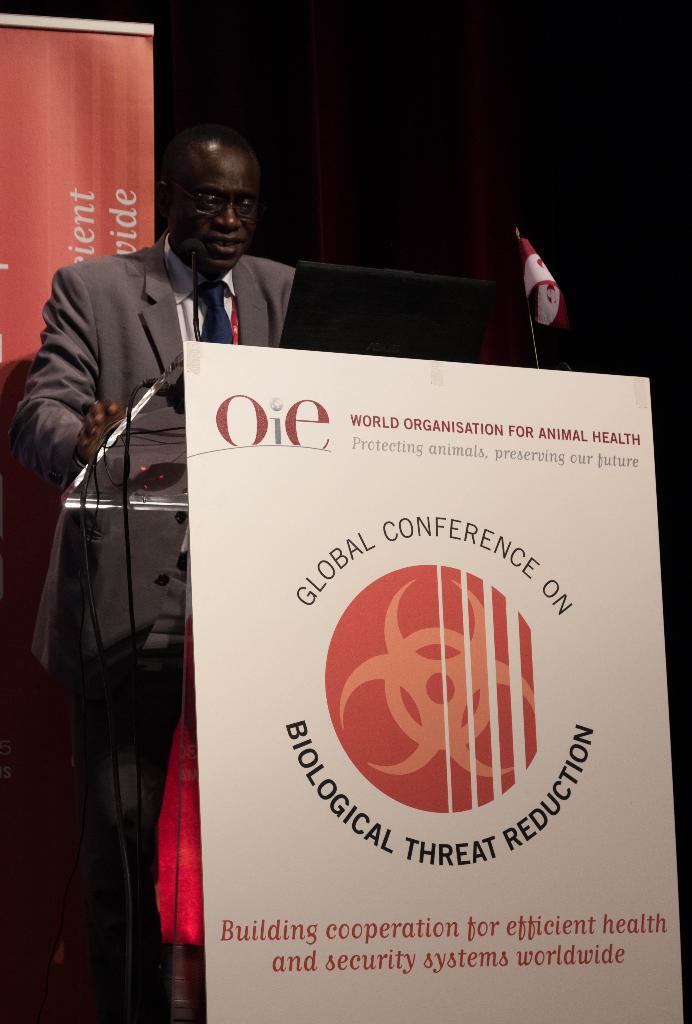What can be seen in the image related to a display or advertisement? There is a poster in the image. What object is present in the image that might be used for public speaking or presentations? There is a podium in the image. What type of object is present in the image that might be used for transmitting signals or power? There is a cable wire in the image. What symbol or emblem can be seen in the image? There is a flag in the image. What device is present in the image that might be used for amplifying sound? There is a microphone in the image. Who is present in the image? There is a man in the image. What can be said about the man's attire in the image? The man is wearing clothes, a tie, and spectacles. What can be seen in the image that might be used for conveying information or instructions? There is a text in the image. Where is the duck located in the image? There is no duck present in the image. What type of clothing is the man wearing in the image? The man is wearing a tie, but there is no mention of a dress in the image. 